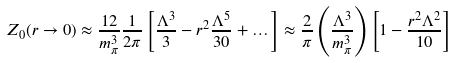Convert formula to latex. <formula><loc_0><loc_0><loc_500><loc_500>Z _ { 0 } ( r \rightarrow 0 ) \approx \frac { 1 2 } { m _ { \pi } ^ { 3 } } \frac { 1 } { 2 \pi } \left [ \frac { \Lambda ^ { 3 } } { 3 } - r ^ { 2 } \frac { \Lambda ^ { 5 } } { 3 0 } + \dots \right ] \approx \frac { 2 } { \pi } \left ( \frac { \Lambda ^ { 3 } } { m _ { \pi } ^ { 3 } } \right ) \left [ 1 - \frac { r ^ { 2 } \Lambda ^ { 2 } } { 1 0 } \right ]</formula> 